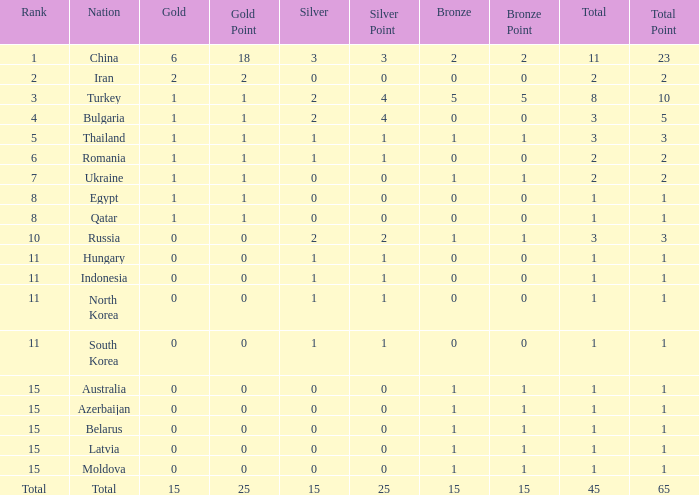Wha is the average number of bronze of hungary, which has less than 1 silver? None. 